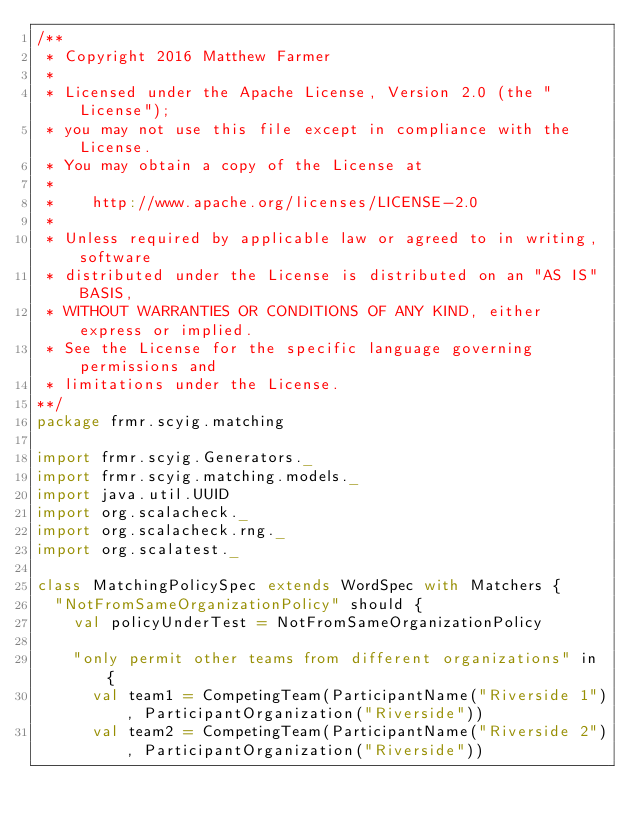<code> <loc_0><loc_0><loc_500><loc_500><_Scala_>/**
 * Copyright 2016 Matthew Farmer
 *
 * Licensed under the Apache License, Version 2.0 (the "License");
 * you may not use this file except in compliance with the License.
 * You may obtain a copy of the License at
 *
 *    http://www.apache.org/licenses/LICENSE-2.0
 *
 * Unless required by applicable law or agreed to in writing, software
 * distributed under the License is distributed on an "AS IS" BASIS,
 * WITHOUT WARRANTIES OR CONDITIONS OF ANY KIND, either express or implied.
 * See the License for the specific language governing permissions and
 * limitations under the License.
**/
package frmr.scyig.matching

import frmr.scyig.Generators._
import frmr.scyig.matching.models._
import java.util.UUID
import org.scalacheck._
import org.scalacheck.rng._
import org.scalatest._

class MatchingPolicySpec extends WordSpec with Matchers {
  "NotFromSameOrganizationPolicy" should {
    val policyUnderTest = NotFromSameOrganizationPolicy

    "only permit other teams from different organizations" in {
      val team1 = CompetingTeam(ParticipantName("Riverside 1"), ParticipantOrganization("Riverside"))
      val team2 = CompetingTeam(ParticipantName("Riverside 2"), ParticipantOrganization("Riverside"))</code> 